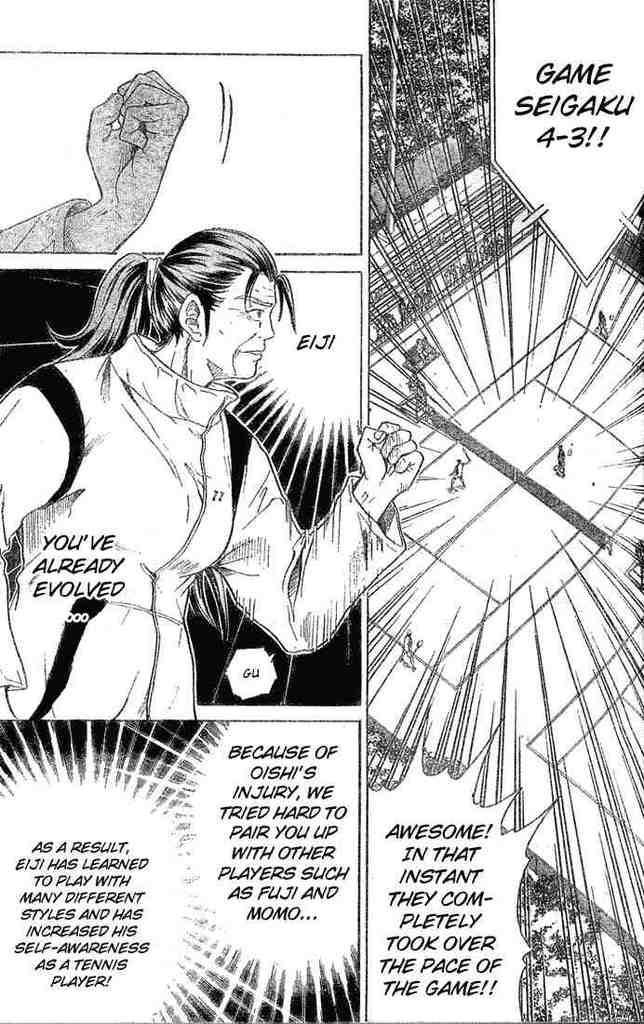How would you summarize this image in a sentence or two? In the image there is a comic art image of a woman in the middle with text all over it. 